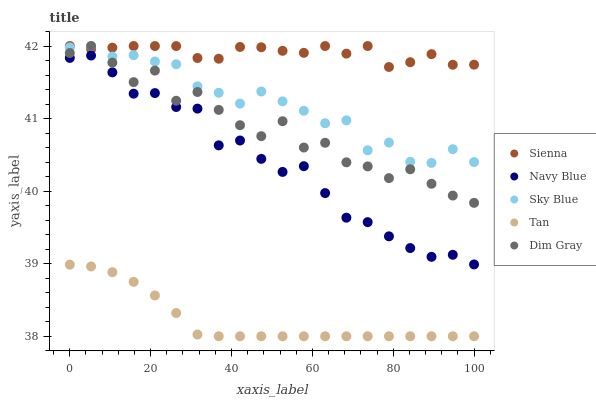Does Tan have the minimum area under the curve?
Answer yes or no. Yes. Does Sienna have the maximum area under the curve?
Answer yes or no. Yes. Does Navy Blue have the minimum area under the curve?
Answer yes or no. No. Does Navy Blue have the maximum area under the curve?
Answer yes or no. No. Is Tan the smoothest?
Answer yes or no. Yes. Is Dim Gray the roughest?
Answer yes or no. Yes. Is Navy Blue the smoothest?
Answer yes or no. No. Is Navy Blue the roughest?
Answer yes or no. No. Does Tan have the lowest value?
Answer yes or no. Yes. Does Navy Blue have the lowest value?
Answer yes or no. No. Does Sky Blue have the highest value?
Answer yes or no. Yes. Does Navy Blue have the highest value?
Answer yes or no. No. Is Tan less than Sienna?
Answer yes or no. Yes. Is Dim Gray greater than Tan?
Answer yes or no. Yes. Does Sienna intersect Dim Gray?
Answer yes or no. Yes. Is Sienna less than Dim Gray?
Answer yes or no. No. Is Sienna greater than Dim Gray?
Answer yes or no. No. Does Tan intersect Sienna?
Answer yes or no. No. 